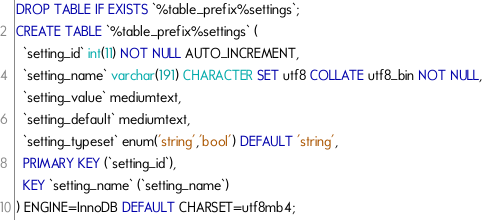Convert code to text. <code><loc_0><loc_0><loc_500><loc_500><_SQL_>DROP TABLE IF EXISTS `%table_prefix%settings`;
CREATE TABLE `%table_prefix%settings` (
  `setting_id` int(11) NOT NULL AUTO_INCREMENT,
  `setting_name` varchar(191) CHARACTER SET utf8 COLLATE utf8_bin NOT NULL,
  `setting_value` mediumtext,
  `setting_default` mediumtext,
  `setting_typeset` enum('string','bool') DEFAULT 'string',
  PRIMARY KEY (`setting_id`),
  KEY `setting_name` (`setting_name`)
) ENGINE=InnoDB DEFAULT CHARSET=utf8mb4;</code> 